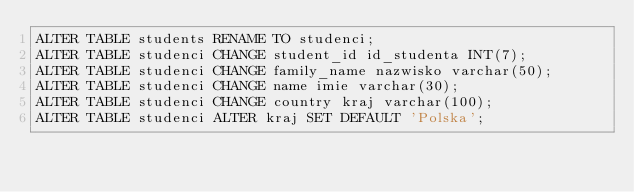<code> <loc_0><loc_0><loc_500><loc_500><_SQL_>ALTER TABLE students RENAME TO studenci;
ALTER TABLE studenci CHANGE student_id id_studenta INT(7);
ALTER TABLE studenci CHANGE family_name nazwisko varchar(50);
ALTER TABLE studenci CHANGE name imie varchar(30);
ALTER TABLE studenci CHANGE country kraj varchar(100);
ALTER TABLE studenci ALTER kraj SET DEFAULT 'Polska';</code> 